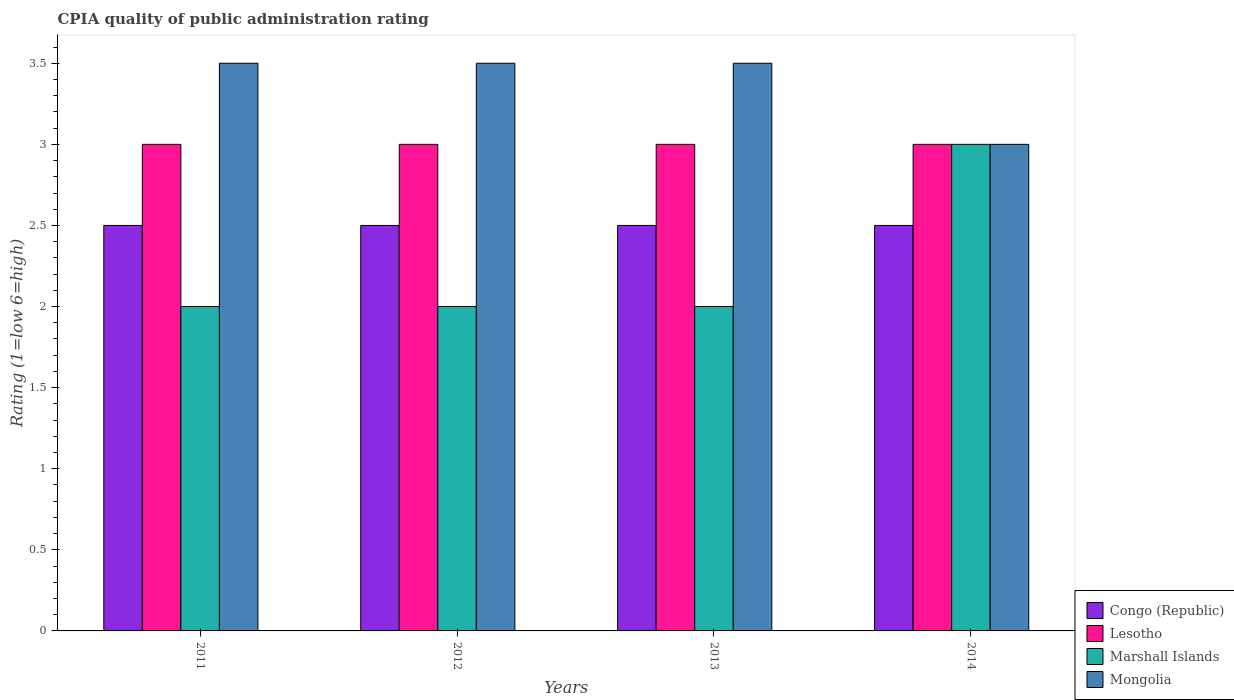Are the number of bars per tick equal to the number of legend labels?
Keep it short and to the point. Yes. How many bars are there on the 1st tick from the left?
Give a very brief answer. 4. How many bars are there on the 1st tick from the right?
Give a very brief answer. 4. Across all years, what is the minimum CPIA rating in Lesotho?
Ensure brevity in your answer.  3. In which year was the CPIA rating in Mongolia maximum?
Your answer should be very brief. 2011. In which year was the CPIA rating in Lesotho minimum?
Offer a very short reply. 2011. What is the total CPIA rating in Mongolia in the graph?
Provide a succinct answer. 13.5. What is the difference between the CPIA rating in Lesotho in 2014 and the CPIA rating in Marshall Islands in 2013?
Make the answer very short. 1. What is the average CPIA rating in Mongolia per year?
Offer a very short reply. 3.38. In how many years, is the CPIA rating in Mongolia greater than 2.9?
Make the answer very short. 4. What is the ratio of the CPIA rating in Mongolia in 2012 to that in 2013?
Your answer should be compact. 1. What is the difference between the highest and the second highest CPIA rating in Mongolia?
Your answer should be compact. 0. What is the difference between the highest and the lowest CPIA rating in Congo (Republic)?
Your answer should be compact. 0. In how many years, is the CPIA rating in Congo (Republic) greater than the average CPIA rating in Congo (Republic) taken over all years?
Give a very brief answer. 0. What does the 1st bar from the left in 2014 represents?
Offer a very short reply. Congo (Republic). What does the 4th bar from the right in 2012 represents?
Keep it short and to the point. Congo (Republic). How many years are there in the graph?
Your answer should be compact. 4. What is the difference between two consecutive major ticks on the Y-axis?
Keep it short and to the point. 0.5. Does the graph contain any zero values?
Your answer should be very brief. No. Does the graph contain grids?
Provide a short and direct response. No. Where does the legend appear in the graph?
Give a very brief answer. Bottom right. What is the title of the graph?
Provide a short and direct response. CPIA quality of public administration rating. What is the label or title of the Y-axis?
Provide a succinct answer. Rating (1=low 6=high). What is the Rating (1=low 6=high) of Mongolia in 2011?
Give a very brief answer. 3.5. What is the Rating (1=low 6=high) in Congo (Republic) in 2012?
Provide a succinct answer. 2.5. What is the Rating (1=low 6=high) of Mongolia in 2012?
Keep it short and to the point. 3.5. What is the Rating (1=low 6=high) of Congo (Republic) in 2013?
Offer a terse response. 2.5. What is the Rating (1=low 6=high) of Lesotho in 2013?
Your response must be concise. 3. What is the Rating (1=low 6=high) of Marshall Islands in 2013?
Offer a very short reply. 2. Across all years, what is the maximum Rating (1=low 6=high) of Marshall Islands?
Make the answer very short. 3. Across all years, what is the minimum Rating (1=low 6=high) in Lesotho?
Your answer should be very brief. 3. Across all years, what is the minimum Rating (1=low 6=high) in Marshall Islands?
Make the answer very short. 2. What is the total Rating (1=low 6=high) in Lesotho in the graph?
Your answer should be compact. 12. What is the difference between the Rating (1=low 6=high) of Mongolia in 2011 and that in 2012?
Your answer should be very brief. 0. What is the difference between the Rating (1=low 6=high) of Congo (Republic) in 2011 and that in 2013?
Provide a short and direct response. 0. What is the difference between the Rating (1=low 6=high) of Marshall Islands in 2011 and that in 2013?
Ensure brevity in your answer.  0. What is the difference between the Rating (1=low 6=high) in Lesotho in 2011 and that in 2014?
Your answer should be very brief. 0. What is the difference between the Rating (1=low 6=high) in Mongolia in 2011 and that in 2014?
Offer a terse response. 0.5. What is the difference between the Rating (1=low 6=high) of Congo (Republic) in 2012 and that in 2013?
Ensure brevity in your answer.  0. What is the difference between the Rating (1=low 6=high) of Lesotho in 2012 and that in 2013?
Provide a short and direct response. 0. What is the difference between the Rating (1=low 6=high) in Mongolia in 2012 and that in 2013?
Keep it short and to the point. 0. What is the difference between the Rating (1=low 6=high) of Congo (Republic) in 2012 and that in 2014?
Ensure brevity in your answer.  0. What is the difference between the Rating (1=low 6=high) in Congo (Republic) in 2011 and the Rating (1=low 6=high) in Mongolia in 2012?
Offer a terse response. -1. What is the difference between the Rating (1=low 6=high) of Lesotho in 2011 and the Rating (1=low 6=high) of Marshall Islands in 2012?
Your answer should be compact. 1. What is the difference between the Rating (1=low 6=high) in Congo (Republic) in 2011 and the Rating (1=low 6=high) in Lesotho in 2013?
Your response must be concise. -0.5. What is the difference between the Rating (1=low 6=high) in Lesotho in 2011 and the Rating (1=low 6=high) in Marshall Islands in 2013?
Your answer should be compact. 1. What is the difference between the Rating (1=low 6=high) in Lesotho in 2011 and the Rating (1=low 6=high) in Mongolia in 2013?
Provide a succinct answer. -0.5. What is the difference between the Rating (1=low 6=high) of Congo (Republic) in 2011 and the Rating (1=low 6=high) of Lesotho in 2014?
Provide a short and direct response. -0.5. What is the difference between the Rating (1=low 6=high) of Congo (Republic) in 2011 and the Rating (1=low 6=high) of Marshall Islands in 2014?
Provide a succinct answer. -0.5. What is the difference between the Rating (1=low 6=high) in Congo (Republic) in 2012 and the Rating (1=low 6=high) in Mongolia in 2013?
Make the answer very short. -1. What is the difference between the Rating (1=low 6=high) of Lesotho in 2012 and the Rating (1=low 6=high) of Mongolia in 2013?
Make the answer very short. -0.5. What is the difference between the Rating (1=low 6=high) in Congo (Republic) in 2012 and the Rating (1=low 6=high) in Mongolia in 2014?
Provide a succinct answer. -0.5. What is the difference between the Rating (1=low 6=high) of Marshall Islands in 2012 and the Rating (1=low 6=high) of Mongolia in 2014?
Your answer should be compact. -1. What is the difference between the Rating (1=low 6=high) in Congo (Republic) in 2013 and the Rating (1=low 6=high) in Lesotho in 2014?
Provide a succinct answer. -0.5. What is the difference between the Rating (1=low 6=high) of Congo (Republic) in 2013 and the Rating (1=low 6=high) of Mongolia in 2014?
Keep it short and to the point. -0.5. What is the difference between the Rating (1=low 6=high) of Lesotho in 2013 and the Rating (1=low 6=high) of Marshall Islands in 2014?
Offer a terse response. 0. What is the difference between the Rating (1=low 6=high) of Lesotho in 2013 and the Rating (1=low 6=high) of Mongolia in 2014?
Your response must be concise. 0. What is the difference between the Rating (1=low 6=high) of Marshall Islands in 2013 and the Rating (1=low 6=high) of Mongolia in 2014?
Provide a short and direct response. -1. What is the average Rating (1=low 6=high) in Marshall Islands per year?
Keep it short and to the point. 2.25. What is the average Rating (1=low 6=high) in Mongolia per year?
Give a very brief answer. 3.38. In the year 2011, what is the difference between the Rating (1=low 6=high) in Congo (Republic) and Rating (1=low 6=high) in Lesotho?
Your answer should be compact. -0.5. In the year 2011, what is the difference between the Rating (1=low 6=high) of Lesotho and Rating (1=low 6=high) of Marshall Islands?
Give a very brief answer. 1. In the year 2012, what is the difference between the Rating (1=low 6=high) in Congo (Republic) and Rating (1=low 6=high) in Mongolia?
Provide a short and direct response. -1. In the year 2012, what is the difference between the Rating (1=low 6=high) of Marshall Islands and Rating (1=low 6=high) of Mongolia?
Keep it short and to the point. -1.5. In the year 2013, what is the difference between the Rating (1=low 6=high) of Congo (Republic) and Rating (1=low 6=high) of Marshall Islands?
Offer a very short reply. 0.5. In the year 2013, what is the difference between the Rating (1=low 6=high) in Lesotho and Rating (1=low 6=high) in Marshall Islands?
Ensure brevity in your answer.  1. In the year 2013, what is the difference between the Rating (1=low 6=high) of Marshall Islands and Rating (1=low 6=high) of Mongolia?
Your answer should be compact. -1.5. In the year 2014, what is the difference between the Rating (1=low 6=high) of Congo (Republic) and Rating (1=low 6=high) of Lesotho?
Offer a very short reply. -0.5. In the year 2014, what is the difference between the Rating (1=low 6=high) in Congo (Republic) and Rating (1=low 6=high) in Marshall Islands?
Your answer should be compact. -0.5. In the year 2014, what is the difference between the Rating (1=low 6=high) of Lesotho and Rating (1=low 6=high) of Marshall Islands?
Offer a terse response. 0. In the year 2014, what is the difference between the Rating (1=low 6=high) in Lesotho and Rating (1=low 6=high) in Mongolia?
Provide a succinct answer. 0. In the year 2014, what is the difference between the Rating (1=low 6=high) of Marshall Islands and Rating (1=low 6=high) of Mongolia?
Your response must be concise. 0. What is the ratio of the Rating (1=low 6=high) of Congo (Republic) in 2011 to that in 2012?
Give a very brief answer. 1. What is the ratio of the Rating (1=low 6=high) in Lesotho in 2011 to that in 2012?
Make the answer very short. 1. What is the ratio of the Rating (1=low 6=high) in Marshall Islands in 2011 to that in 2012?
Give a very brief answer. 1. What is the ratio of the Rating (1=low 6=high) in Mongolia in 2011 to that in 2012?
Your response must be concise. 1. What is the ratio of the Rating (1=low 6=high) in Marshall Islands in 2011 to that in 2013?
Give a very brief answer. 1. What is the ratio of the Rating (1=low 6=high) of Lesotho in 2011 to that in 2014?
Ensure brevity in your answer.  1. What is the ratio of the Rating (1=low 6=high) of Marshall Islands in 2011 to that in 2014?
Your answer should be compact. 0.67. What is the ratio of the Rating (1=low 6=high) in Mongolia in 2012 to that in 2013?
Your response must be concise. 1. What is the ratio of the Rating (1=low 6=high) of Lesotho in 2012 to that in 2014?
Provide a succinct answer. 1. What is the ratio of the Rating (1=low 6=high) of Marshall Islands in 2012 to that in 2014?
Offer a very short reply. 0.67. What is the ratio of the Rating (1=low 6=high) of Congo (Republic) in 2013 to that in 2014?
Keep it short and to the point. 1. What is the ratio of the Rating (1=low 6=high) in Mongolia in 2013 to that in 2014?
Provide a succinct answer. 1.17. What is the difference between the highest and the second highest Rating (1=low 6=high) of Congo (Republic)?
Your answer should be very brief. 0. What is the difference between the highest and the second highest Rating (1=low 6=high) in Marshall Islands?
Your answer should be very brief. 1. What is the difference between the highest and the second highest Rating (1=low 6=high) of Mongolia?
Keep it short and to the point. 0. 